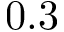<formula> <loc_0><loc_0><loc_500><loc_500>0 . 3</formula> 